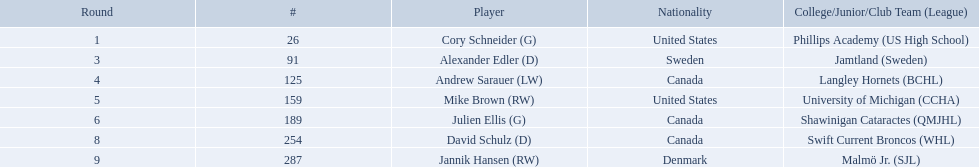Who are the players? Cory Schneider (G), Alexander Edler (D), Andrew Sarauer (LW), Mike Brown (RW), Julien Ellis (G), David Schulz (D), Jannik Hansen (RW). Of those, who is from denmark? Jannik Hansen (RW). Who were the players in the 2004-05 vancouver canucks season Cory Schneider (G), Alexander Edler (D), Andrew Sarauer (LW), Mike Brown (RW), Julien Ellis (G), David Schulz (D), Jannik Hansen (RW). Of these players who had a nationality of denmark? Jannik Hansen (RW). Who are the team members? Cory Schneider (G), Alexander Edler (D), Andrew Sarauer (LW), Mike Brown (RW), Julien Ellis (G), David Schulz (D), Jannik Hansen (RW). From them, who comes from denmark? Jannik Hansen (RW). Who are all the members? Cory Schneider (G), Alexander Edler (D), Andrew Sarauer (LW), Mike Brown (RW), Julien Ellis (G), David Schulz (D), Jannik Hansen (RW). What is the citizenship of each member? United States, Sweden, Canada, United States, Canada, Canada, Denmark. Where did they receive education? Phillips Academy (US High School), Jamtland (Sweden), Langley Hornets (BCHL), University of Michigan (CCHA), Shawinigan Cataractes (QMJHL), Swift Current Broncos (WHL), Malmö Jr. (SJL). Which member attended langley hornets? Andrew Sarauer (LW). Who are the participants? Cory Schneider (G), Alexander Edler (D), Andrew Sarauer (LW), Mike Brown (RW), Julien Ellis (G), David Schulz (D), Jannik Hansen (RW). Among them, who hails from denmark? Jannik Hansen (RW). What countries do the players represent? United States, Sweden, Canada, United States, Canada, Canada, Denmark. Which player identifies themselves as danish? Jannik Hansen (RW). Parse the table in full. {'header': ['Round', '#', 'Player', 'Nationality', 'College/Junior/Club Team (League)'], 'rows': [['1', '26', 'Cory Schneider (G)', 'United States', 'Phillips Academy (US High School)'], ['3', '91', 'Alexander Edler (D)', 'Sweden', 'Jamtland (Sweden)'], ['4', '125', 'Andrew Sarauer (LW)', 'Canada', 'Langley Hornets (BCHL)'], ['5', '159', 'Mike Brown (RW)', 'United States', 'University of Michigan (CCHA)'], ['6', '189', 'Julien Ellis (G)', 'Canada', 'Shawinigan Cataractes (QMJHL)'], ['8', '254', 'David Schulz (D)', 'Canada', 'Swift Current Broncos (WHL)'], ['9', '287', 'Jannik Hansen (RW)', 'Denmark', 'Malmö Jr. (SJL)']]} What are the identities of the colleges and junior leagues attended by the players? Phillips Academy (US High School), Jamtland (Sweden), Langley Hornets (BCHL), University of Michigan (CCHA), Shawinigan Cataractes (QMJHL), Swift Current Broncos (WHL), Malmö Jr. (SJL). Also, which player was a member of the langley hornets team? Andrew Sarauer (LW). 